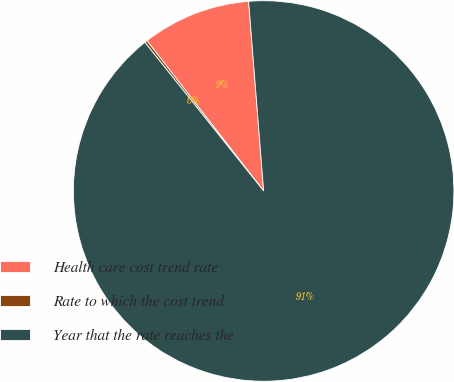<chart> <loc_0><loc_0><loc_500><loc_500><pie_chart><fcel>Health care cost trend rate<fcel>Rate to which the cost trend<fcel>Year that the rate reaches the<nl><fcel>9.25%<fcel>0.22%<fcel>90.52%<nl></chart> 